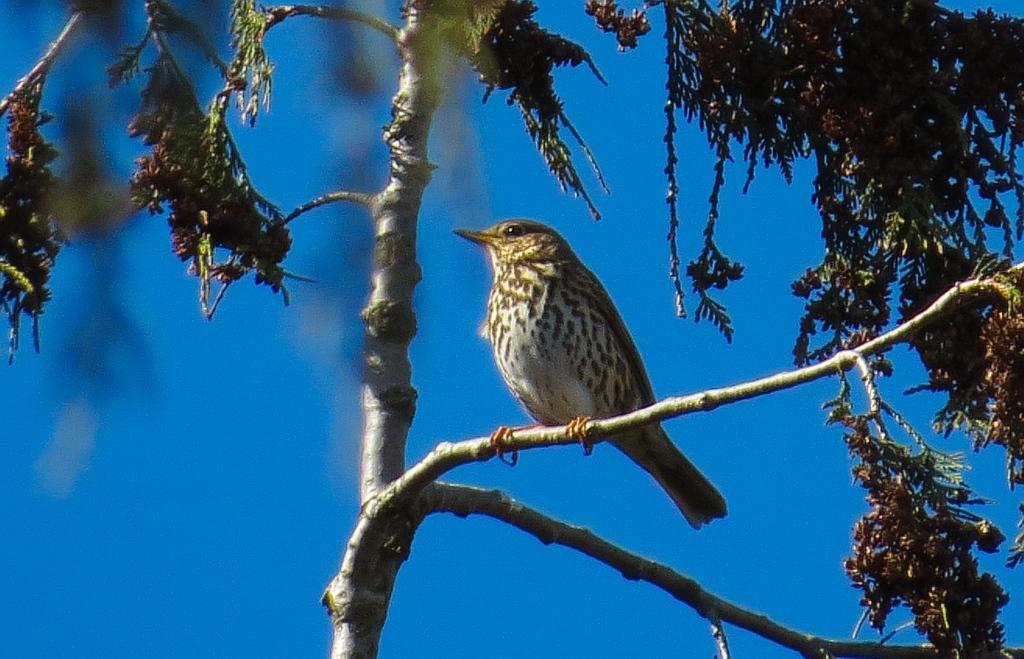What type of animal is in the image? There is a bird in the image. Where is the bird located? The bird is on a branch of a tree. What can be seen in the background of the image? The sky is visible in the background of the image. What type of tramp can be seen in the image? There is no tramp present in the image; it features a bird on a tree branch with the sky visible in the background. 